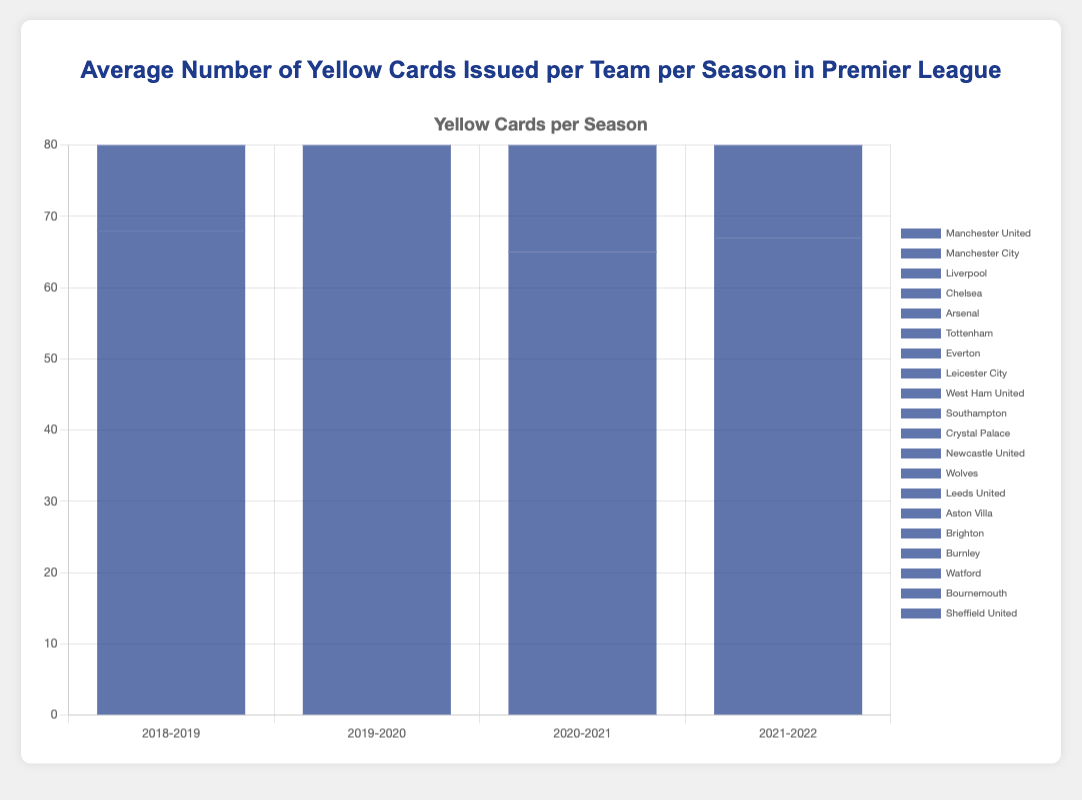What was the highest number of yellow cards issued to any team in the 2019-2020 season? To find the highest number of yellow cards issued to any team in a specific season, we need to look at the data for that season and identify the maximum value. For the 2019-2020 season, the highest number is 75 issued to Burnley and Everton.
Answer: 75 Which team had the most consistent number of yellow cards across all four seasons? To determine consistency, we should look at the variability in the values for each team across the seasons. Manchester United has the values of 68, 70, 65, and 67, indicating very low fluctuation.
Answer: Manchester United What was the average number of yellow cards issued to Tottenham across the four seasons? To find the average, add up the number of yellow cards for Tottenham across all seasons and divide by the number of seasons: (63 + 65 + 60 + 62) / 4 = 250 / 4 = 62.5.
Answer: 62.5 Which season had the highest total number of yellow cards issued across all teams? Sum the number of yellow cards for all teams in each season and compare the totals. Adding the values:
* 2018-2019: 1176
* 2019-2020: 1203
* 2020-2021: 1081
* 2021-2022: 1163.
The highest total is in 2019-2020.
Answer: 2019-2020 In which season did Manchester City receive the least number of yellow cards, and what was that number? Look at the values for Manchester City in each season and identify the minimum. The values are 64, 61, 58, and 63. The minimum is 58 in 2020-2021.
Answer: 2020-2021, 58 How many more yellow cards did Manchester United receive in the 2019-2020 season compared to Liverpool in the 2021-2022 season? Subtract the number of yellow cards Liverpool received in 2021-2022 from the number Manchester United received in 2019-2020: 70 - 61 = 9.
Answer: 9 Which team received exactly 62 yellow cards in the 2021-2022 season? Look at the values for the 2021-2022 season and find the team with 62 yellow cards. Southampton is that team.
Answer: Southampton 